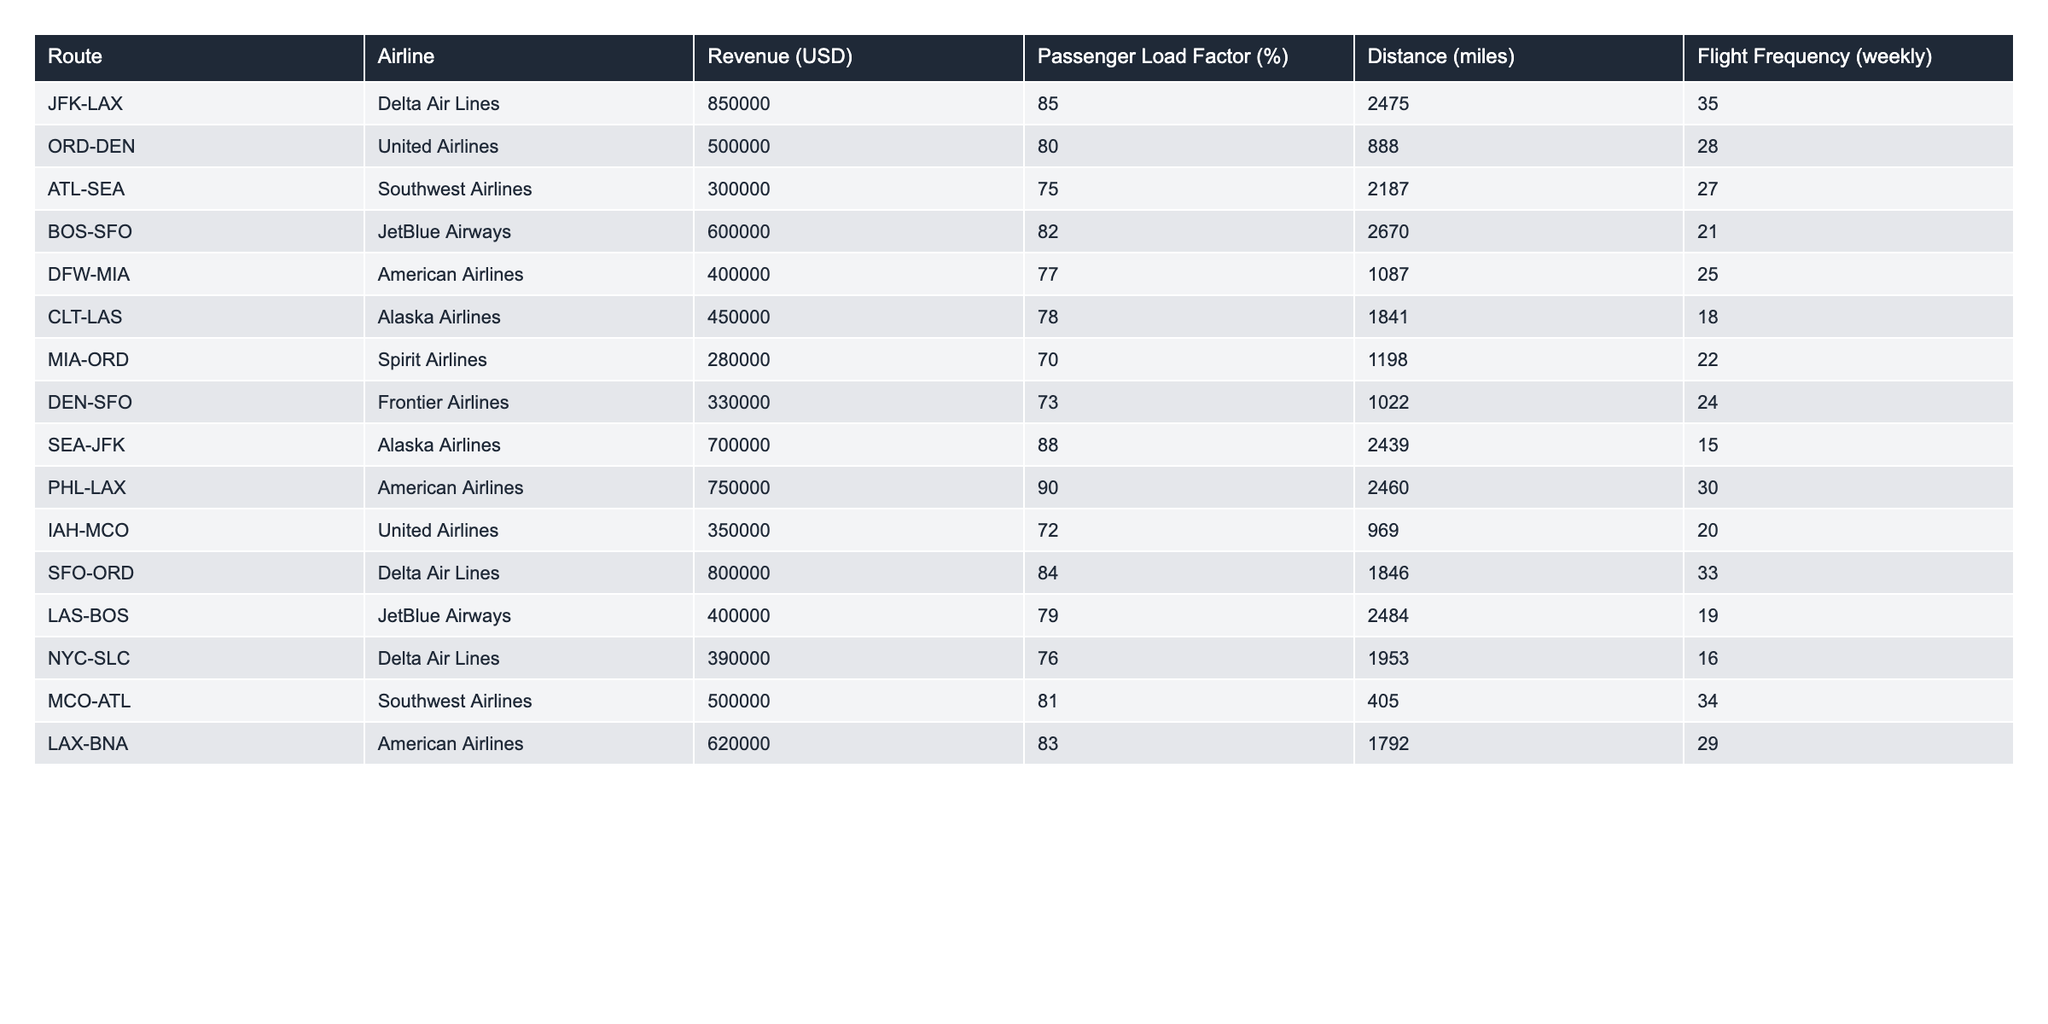What is the revenue for the JFK-LAX route? The revenue for the JFK-LAX route is directly provided in the table under the "Revenue (USD)" column. The value corresponding to this route is $850,000.
Answer: 850000 Which airline operates the highest revenue route? By comparing the revenue column values in the table, the highest revenue is $850,000 for the JFK-LAX route operated by Delta Air Lines.
Answer: Delta Air Lines What is the passenger load factor for the PHL-LAX route? The passenger load factor for the PHL-LAX route is located in the "Passenger Load Factor (%)" column next to the PHL-LAX entry, which shows 90%.
Answer: 90 How many routes have a passenger load factor above 80%? We count the number of routes where the "Passenger Load Factor (%)" is greater than 80%. These routes are JFK-LAX, PHL-LAX, SEA-JFK, and SFO-ORD, amounting to 4 routes.
Answer: 4 Which route has the lowest revenue? By examining the "Revenue (USD)" column, we can identify that the route with the lowest revenue is MIA-ORD, which has $280,000.
Answer: MIA-ORD What is the average passenger load factor across all routes? First, we sum up all the passenger load factor values: 85 + 80 + 75 + 82 + 77 + 78 + 70 + 73 + 88 + 90 + 72 + 84 + 79 + 76 + 81 + 83 = 1,249. Then we divide by the total number of routes, which is 16, resulting in an average passenger load factor of 78.06%.
Answer: 78.06 Is the distance for the LAX-BNA route greater than 2000 miles? The distance for the LAX-BNA route, as shown in the table, is 1,792 miles, which is less than 2000 miles. Hence, the answer is no.
Answer: No What is the total revenue from all routes operated by American Airlines? We will sum the revenue values for routes operated by American Airlines, which are DFW-MIA ($400,000), PHL-LAX ($750,000), and LAX-BNA ($620,000). This results in a total revenue of $400,000 + $750,000 + $620,000 = $1,770,000.
Answer: 1770000 Which airline has the highest flight frequency? To find this, we look at the "Flight Frequency (weekly)" column and identify the maximum value, which is 35 for the JFK-LAX route operated by Delta Air Lines.
Answer: Delta Air Lines How does the revenue of JetBlue Airways compare to United Airlines? JetBlue Airways has routes with revenues of $600,000 (BOS-SFO) and $400,000 (LAS-BOS), while United Airlines has revenues of $500,000 (ORD-DEN) and $350,000 (IAH-MCO). JetBlue Airways has a total revenue of $1,000,000, which is higher than United Airlines' $850,000.
Answer: JetBlue Airways has higher revenue 